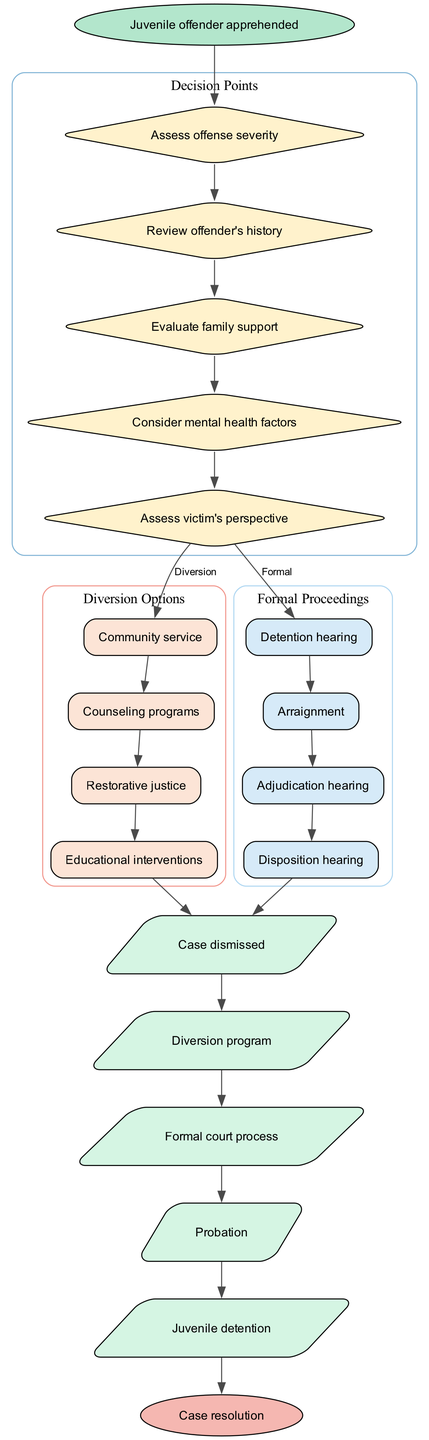What is the starting point of the diagram? The starting point of the diagram is labeled as "Juvenile offender apprehended," which indicates the beginning of the decision-making process.
Answer: Juvenile offender apprehended How many decision points are there in the diagram? The diagram includes five decision points that assess various factors before determining the course of action for the juvenile offender.
Answer: 5 What are the options available for diversion? The diversion options listed in the diagram include Community service, Counseling programs, Restorative justice, and Educational interventions.
Answer: Community service, Counseling programs, Restorative justice, Educational interventions What follows the last decision point? After the last decision point, the options presented are "Diversion" which leads to diversion options, and "Formal" which leads to formal proceedings.
Answer: Diversion and Formal Which outcome leads to a case dismissal? The outcome labeled "Case dismissed" is the result after the diversion options have been completed.
Answer: Case dismissed What type of node represents the family support evaluation? The family support evaluation occurs at one of the decision points represented by a diamond-shape node in the diagram.
Answer: Diamond How many outcomes are listed in the diagram? The diagram lists five outcomes that represent different resolutions for the juvenile cases.
Answer: 5 Which diversion option is the first in the diagram? The first diversion option listed in the diagram is "Community service," which is the initial choice for diversion programs.
Answer: Community service Which proceedings are associated with formal court processes? The proceedings associated with formal court processes in the diagram include Detention hearing, Arraignment, Adjudication hearing, and Disposition hearing.
Answer: Detention hearing, Arraignment, Adjudication hearing, Disposition hearing 